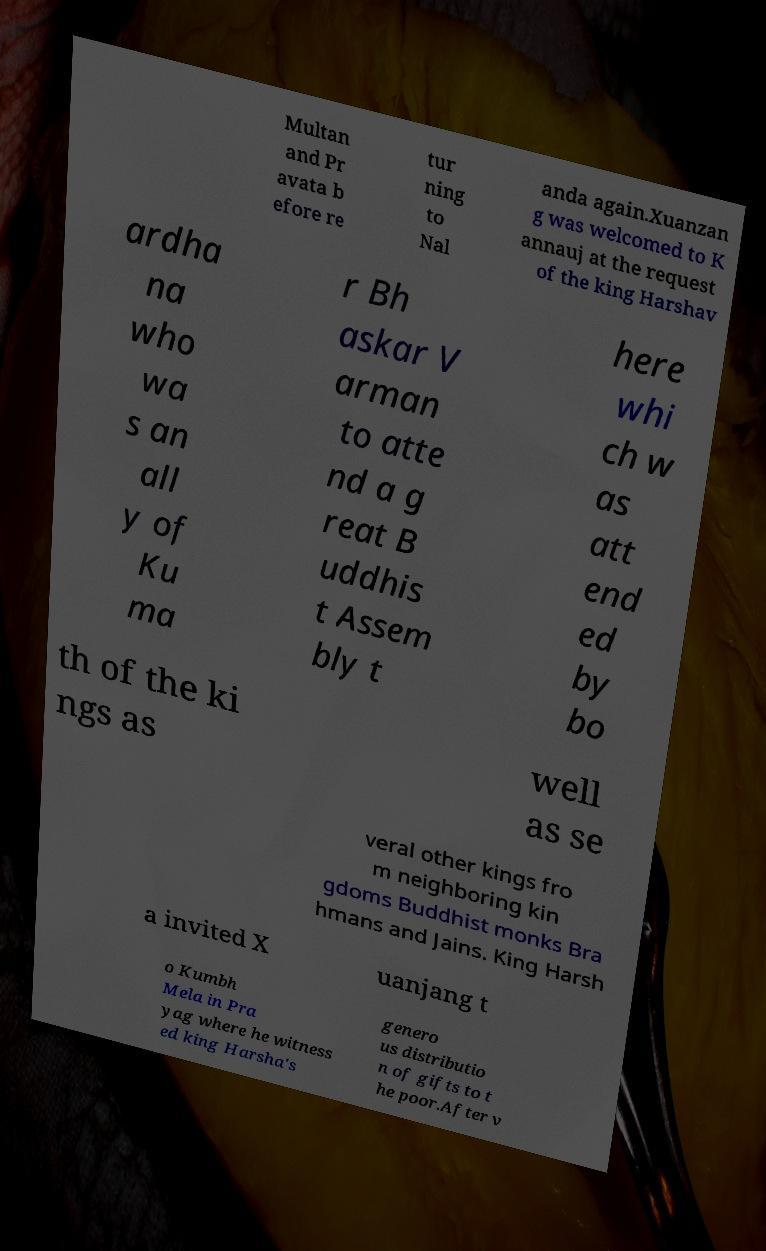Can you read and provide the text displayed in the image?This photo seems to have some interesting text. Can you extract and type it out for me? Multan and Pr avata b efore re tur ning to Nal anda again.Xuanzan g was welcomed to K annauj at the request of the king Harshav ardha na who wa s an all y of Ku ma r Bh askar V arman to atte nd a g reat B uddhis t Assem bly t here whi ch w as att end ed by bo th of the ki ngs as well as se veral other kings fro m neighboring kin gdoms Buddhist monks Bra hmans and Jains. King Harsh a invited X uanjang t o Kumbh Mela in Pra yag where he witness ed king Harsha's genero us distributio n of gifts to t he poor.After v 